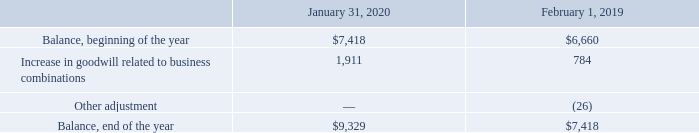Goodwill
The following table summarizes the changes in the carrying amount of goodwill during the periods presented (table in millions):
Which years does the table provide information for the changes in the carrying amount of goodwill? 2020, 2019. What was the increase in goodwill related to business combinations in 2019?
Answer scale should be: million. 784. What was the balance at the end of the year in 2020?
Answer scale should be: million. 9,329. What was the change in the Increase in goodwill related to business combinations between 2019 and 2020?
Answer scale should be: million. 1,911-784
Answer: 1127. What was the change in balance at the beginning of the year between 2019 and 2020?
Answer scale should be: million. 7,418-6,660
Answer: 758. What was the percentage change in the balance at the end of the year between 2019 and 2020?
Answer scale should be: percent. (9,329-7,418)/7,418
Answer: 25.76. 